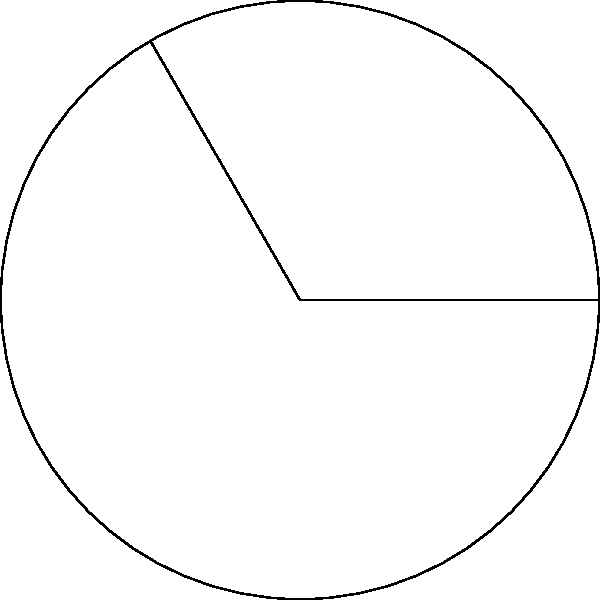In a circular protest area in Bangkok, activists are occupying a sector of the circle. If the radius of the circular area is 300 meters and the central angle of the occupied sector is 120°, what is the area of the protest zone? (Use π ≈ 3.14) To find the area of a circular sector, we need to follow these steps:

1. Recall the formula for the area of a circular sector:
   $$A = \frac{\theta}{360°} \cdot \pi r^2$$
   where $A$ is the area, $\theta$ is the central angle in degrees, and $r$ is the radius.

2. Given information:
   - Radius (r) = 300 meters
   - Central angle (θ) = 120°
   - π ≈ 3.14

3. Substitute the values into the formula:
   $$A = \frac{120°}{360°} \cdot 3.14 \cdot 300^2$$

4. Simplify:
   $$A = \frac{1}{3} \cdot 3.14 \cdot 90,000$$

5. Calculate:
   $$A = 94,200 \text{ square meters}$$

Therefore, the area of the protest zone is approximately 94,200 square meters.
Answer: 94,200 square meters 